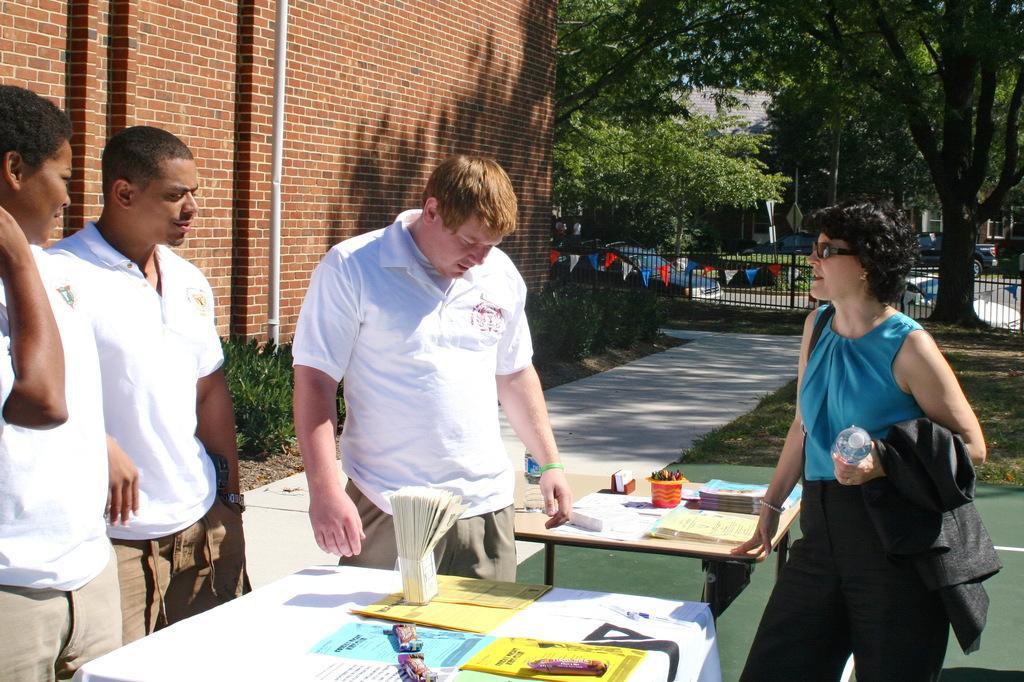Please provide a concise description of this image. There are four people standing on a road. There is a table. There is a paper and stamp board on a table. We can see in the background there is a red wall brick and trees. On the right side we have a woman. She is holding bottle. 